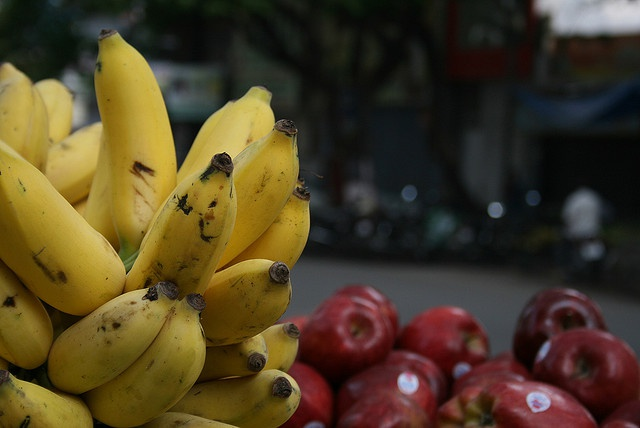Describe the objects in this image and their specific colors. I can see banana in black, olive, and tan tones, apple in black, maroon, and brown tones, and apple in black, maroon, brown, and gray tones in this image. 